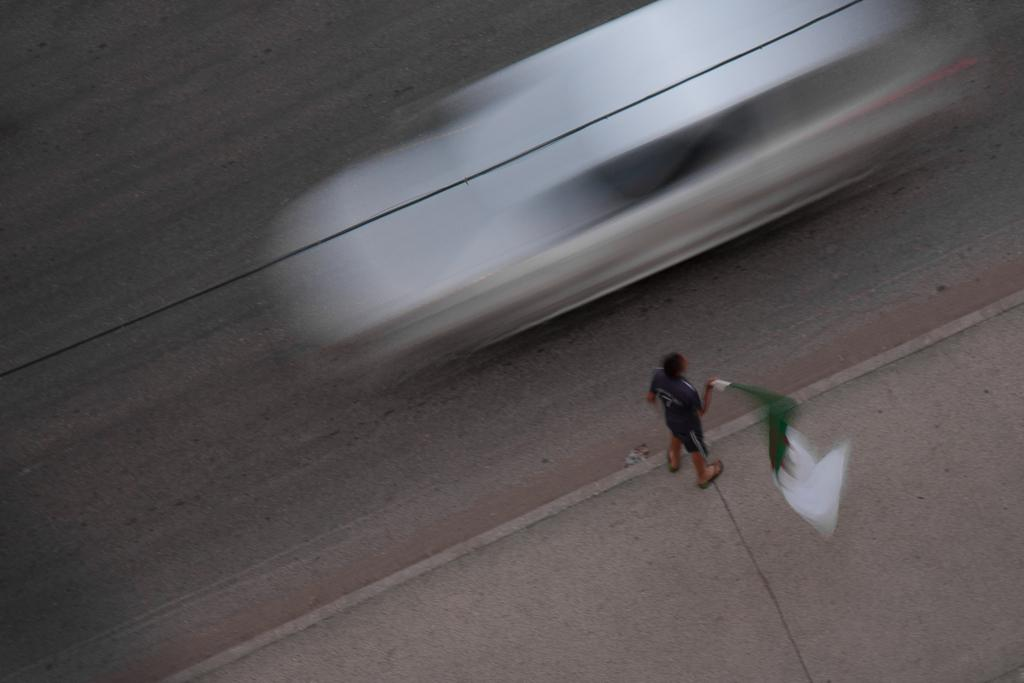What is the person in the image doing? The person is holding a flag in their hand. Where is the person standing in the image? The person is standing on a footpath. What else can be seen in the image besides the person? There is a vehicle visible at the top of the image, and it is on a road. What type of oven is visible in the image? There is no oven present in the image. How many snails can be seen crawling on the person's shoes in the image? There are no snails visible in the image. 